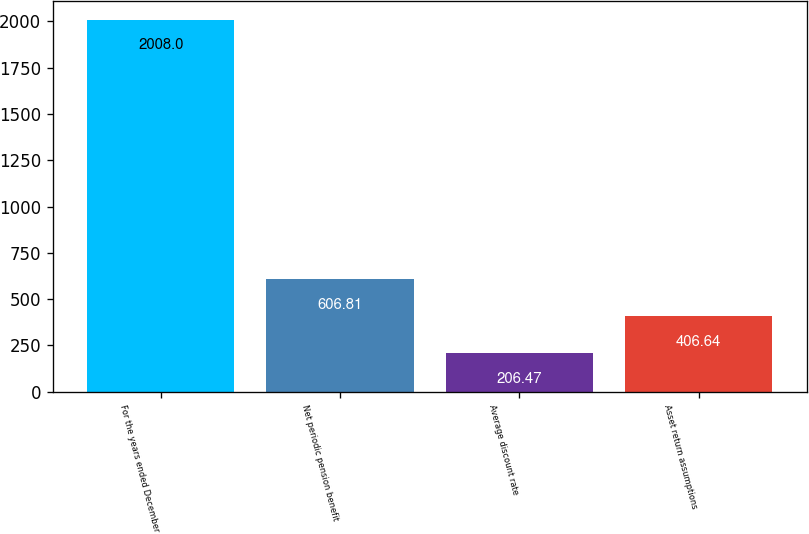Convert chart to OTSL. <chart><loc_0><loc_0><loc_500><loc_500><bar_chart><fcel>For the years ended December<fcel>Net periodic pension benefit<fcel>Average discount rate<fcel>Asset return assumptions<nl><fcel>2008<fcel>606.81<fcel>206.47<fcel>406.64<nl></chart> 